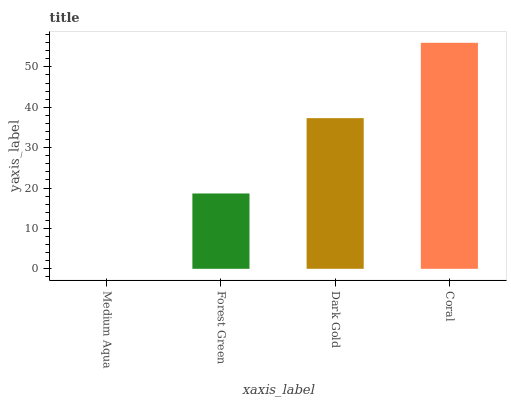Is Medium Aqua the minimum?
Answer yes or no. Yes. Is Coral the maximum?
Answer yes or no. Yes. Is Forest Green the minimum?
Answer yes or no. No. Is Forest Green the maximum?
Answer yes or no. No. Is Forest Green greater than Medium Aqua?
Answer yes or no. Yes. Is Medium Aqua less than Forest Green?
Answer yes or no. Yes. Is Medium Aqua greater than Forest Green?
Answer yes or no. No. Is Forest Green less than Medium Aqua?
Answer yes or no. No. Is Dark Gold the high median?
Answer yes or no. Yes. Is Forest Green the low median?
Answer yes or no. Yes. Is Forest Green the high median?
Answer yes or no. No. Is Coral the low median?
Answer yes or no. No. 